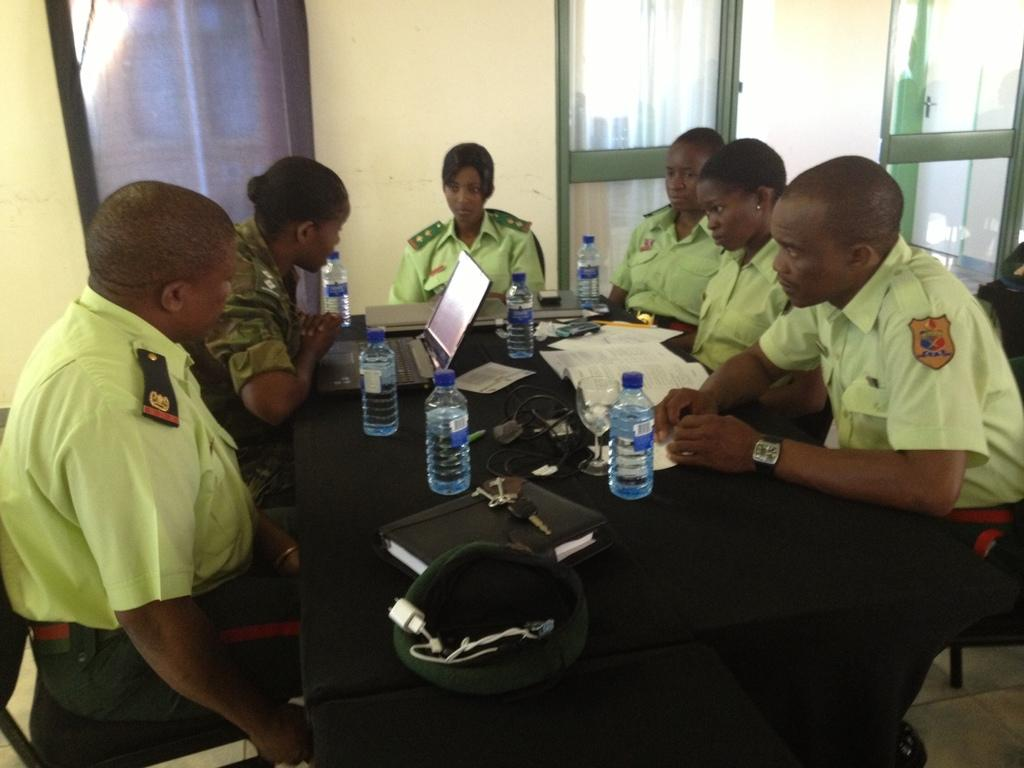What is happening in the image? There is a group of people in the image, and they are sitting together around a table. What are the people wearing? The people are wearing green color shirts. What can be seen on the table? There are water bottles on the table. What type of ring is being passed around the table in the image? There is no ring present in the image; the people are wearing green color shirts and sitting around a table with water bottles. What dish is being served for dinner in the image? The image does not show any food or mention dinner, so it cannot be determined what dish is being served. 